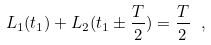<formula> <loc_0><loc_0><loc_500><loc_500>L _ { 1 } ( t _ { 1 } ) + L _ { 2 } ( t _ { 1 } \pm \frac { T } { 2 } ) = \frac { T } { 2 } \ ,</formula> 